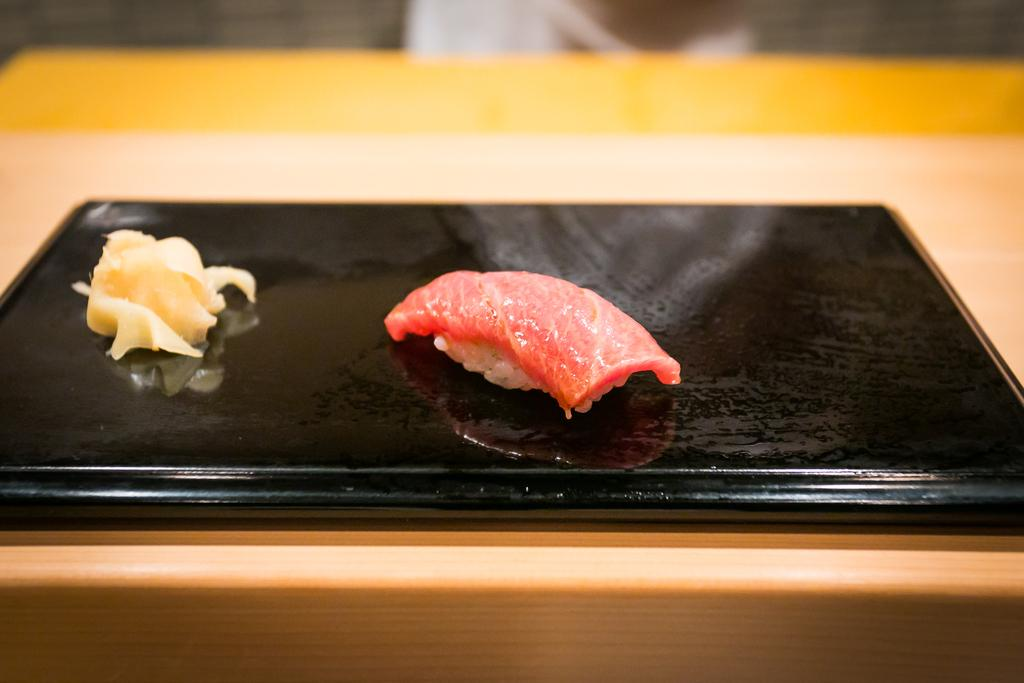What is the main object in the image? There is a menu card in the image. What is on the menu card? The menu card has flesh on it. Where is the menu card located? The menu card is on a table at the bottom of the image. What type of leather can be seen on the plane in the image? There is no plane present in the image, so there is no leather to observe. 